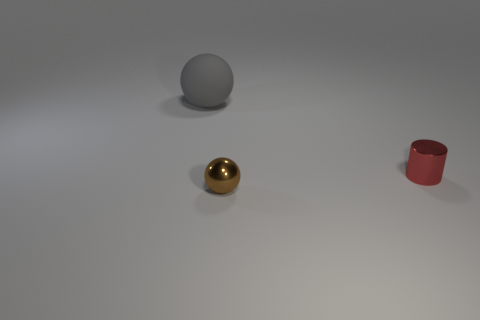Add 3 large red rubber balls. How many objects exist? 6 Subtract all gray spheres. How many spheres are left? 1 Subtract all spheres. How many objects are left? 1 Add 1 purple metallic cylinders. How many purple metallic cylinders exist? 1 Subtract 0 blue spheres. How many objects are left? 3 Subtract all brown cylinders. Subtract all green cubes. How many cylinders are left? 1 Subtract all brown blocks. Subtract all tiny objects. How many objects are left? 1 Add 2 balls. How many balls are left? 4 